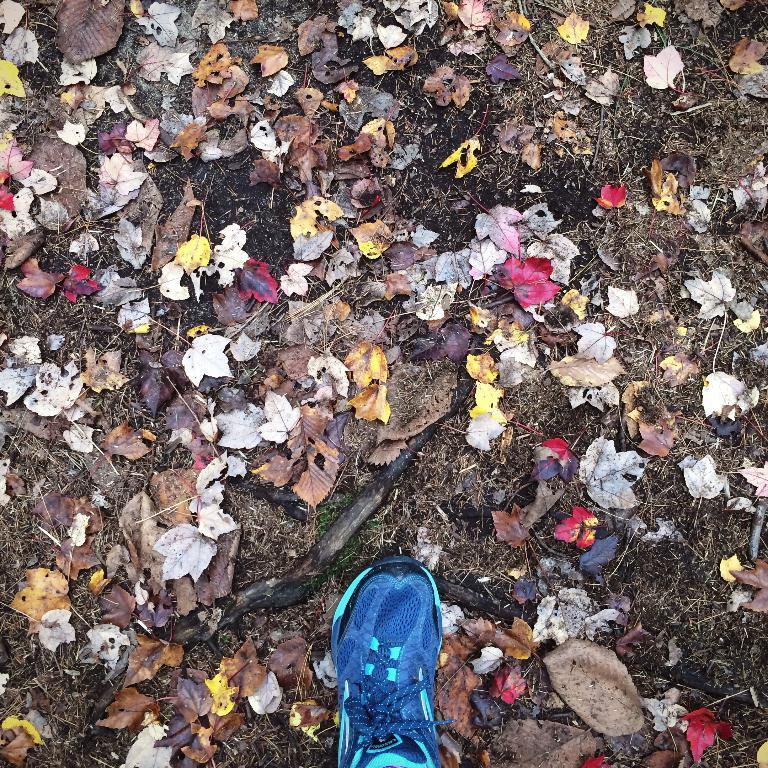What is happening in the image? There is a show in the image. What can be seen on the ground in the image? There are dried leaves and grass on the ground in the image. What type of tax is being discussed at the show in the image? There is no mention of tax or any discussion about it in the image. 